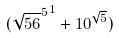Convert formula to latex. <formula><loc_0><loc_0><loc_500><loc_500>( { \sqrt { 5 6 } ^ { 5 } } ^ { 1 } + 1 0 ^ { \sqrt { 5 } } )</formula> 